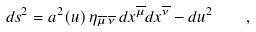Convert formula to latex. <formula><loc_0><loc_0><loc_500><loc_500>d s ^ { 2 } = a ^ { 2 } ( u ) \, \eta _ { \overline { \mu } \, \overline { \nu } } \, d x ^ { \overline { \mu } } d x ^ { \overline { \nu } } - d u ^ { 2 } \quad ,</formula> 